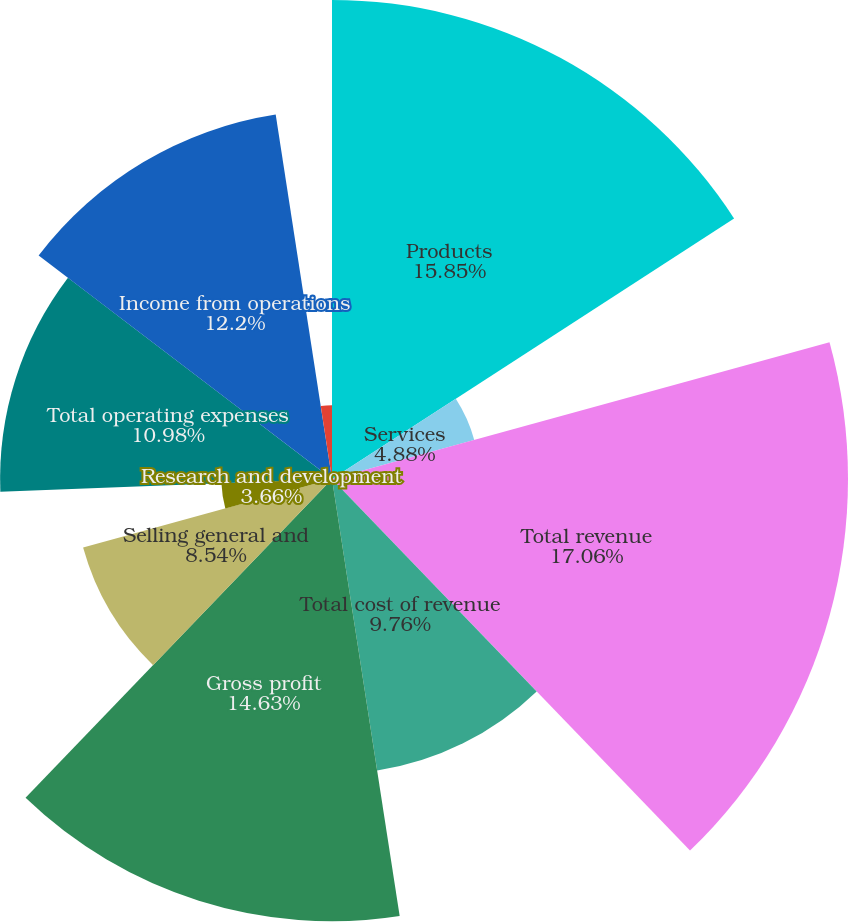Convert chart. <chart><loc_0><loc_0><loc_500><loc_500><pie_chart><fcel>Products<fcel>Services<fcel>Total revenue<fcel>Total cost of revenue<fcel>Gross profit<fcel>Selling general and<fcel>Research and development<fcel>Total operating expenses<fcel>Income from operations<fcel>Interest and other income net<nl><fcel>15.85%<fcel>4.88%<fcel>17.07%<fcel>9.76%<fcel>14.63%<fcel>8.54%<fcel>3.66%<fcel>10.98%<fcel>12.2%<fcel>2.44%<nl></chart> 